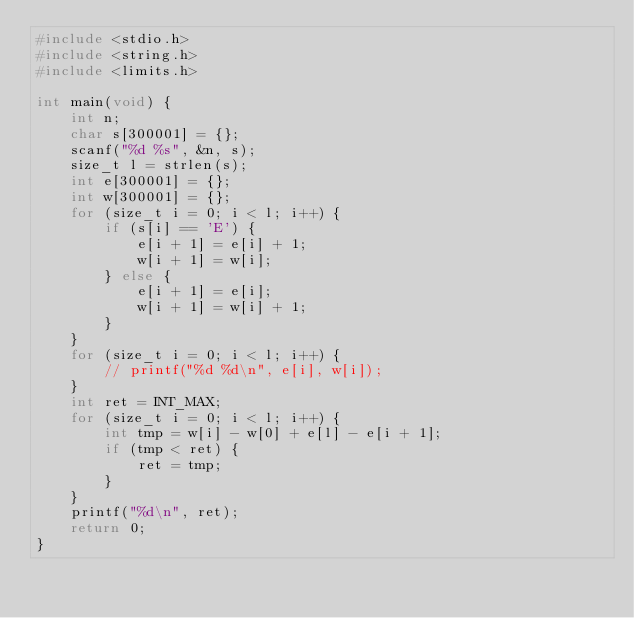Convert code to text. <code><loc_0><loc_0><loc_500><loc_500><_C_>#include <stdio.h>
#include <string.h>
#include <limits.h>

int main(void) {
    int n;
    char s[300001] = {};
    scanf("%d %s", &n, s);
    size_t l = strlen(s);
    int e[300001] = {};
    int w[300001] = {};
    for (size_t i = 0; i < l; i++) {
        if (s[i] == 'E') {
            e[i + 1] = e[i] + 1;
            w[i + 1] = w[i];
        } else {
            e[i + 1] = e[i];
            w[i + 1] = w[i] + 1;
        }
    }
    for (size_t i = 0; i < l; i++) {
        // printf("%d %d\n", e[i], w[i]);
    }
    int ret = INT_MAX;
    for (size_t i = 0; i < l; i++) {
        int tmp = w[i] - w[0] + e[l] - e[i + 1];
        if (tmp < ret) {
            ret = tmp;
        }
    }
    printf("%d\n", ret);
    return 0;
}</code> 